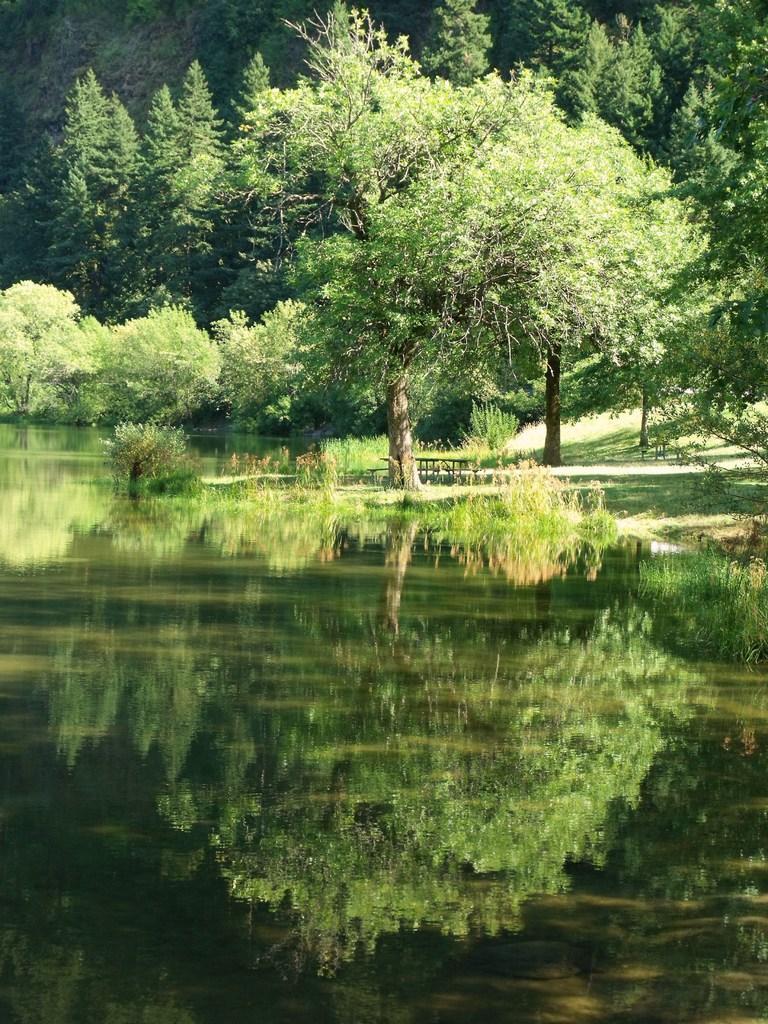How would you summarize this image in a sentence or two? This picture might be taken from forest. In this image, in the background, we can see some trees and plants. At the top, we can see a sky, at the bottom, we can see a water in a lake. 